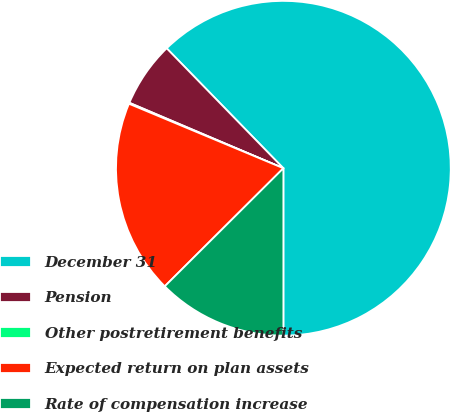<chart> <loc_0><loc_0><loc_500><loc_500><pie_chart><fcel>December 31<fcel>Pension<fcel>Other postretirement benefits<fcel>Expected return on plan assets<fcel>Rate of compensation increase<nl><fcel>62.28%<fcel>6.32%<fcel>0.1%<fcel>18.76%<fcel>12.54%<nl></chart> 